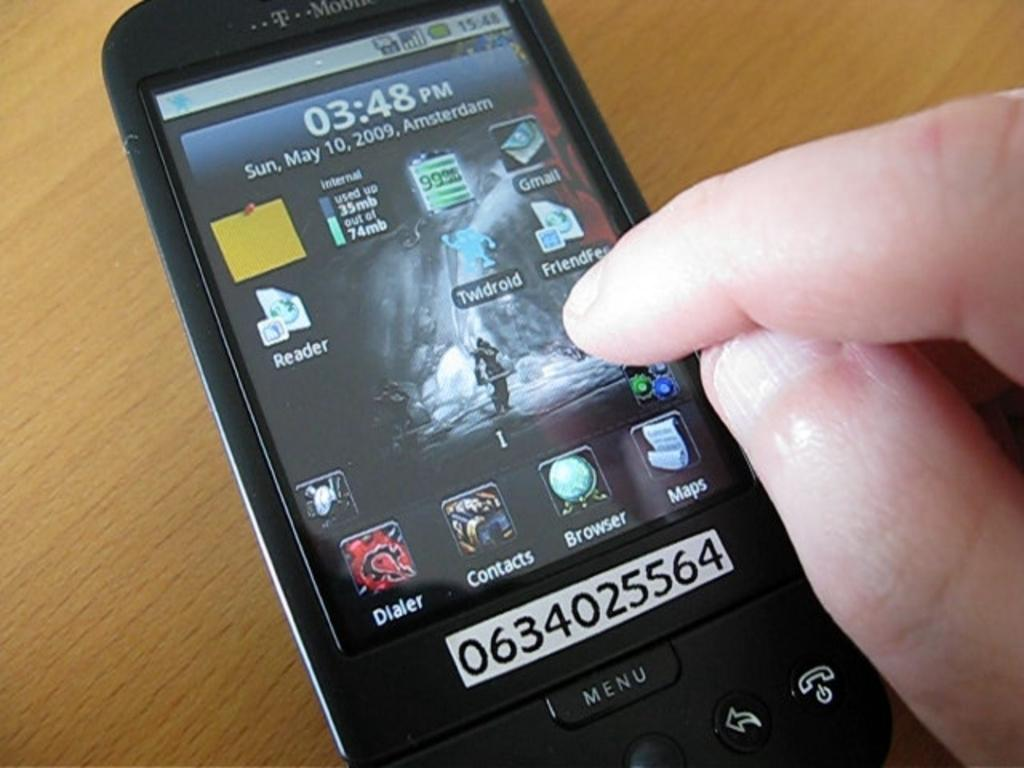<image>
Relay a brief, clear account of the picture shown. a smart phone displaying the time 03.48 pm. 